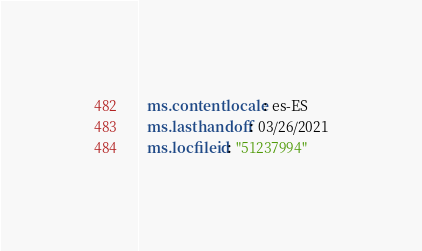Convert code to text. <code><loc_0><loc_0><loc_500><loc_500><_YAML_>  ms.contentlocale: es-ES
  ms.lasthandoff: 03/26/2021
  ms.locfileid: "51237994"
</code> 